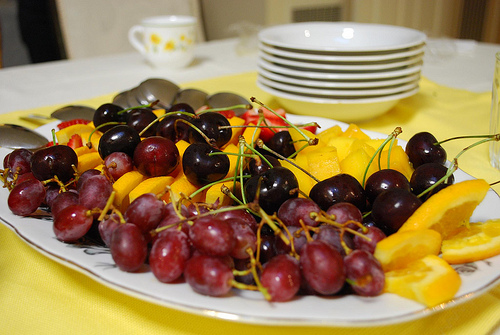<image>
Can you confirm if the cherry is to the left of the cherry? No. The cherry is not to the left of the cherry. From this viewpoint, they have a different horizontal relationship. Is the grapes in front of the cherries? Yes. The grapes is positioned in front of the cherries, appearing closer to the camera viewpoint. 